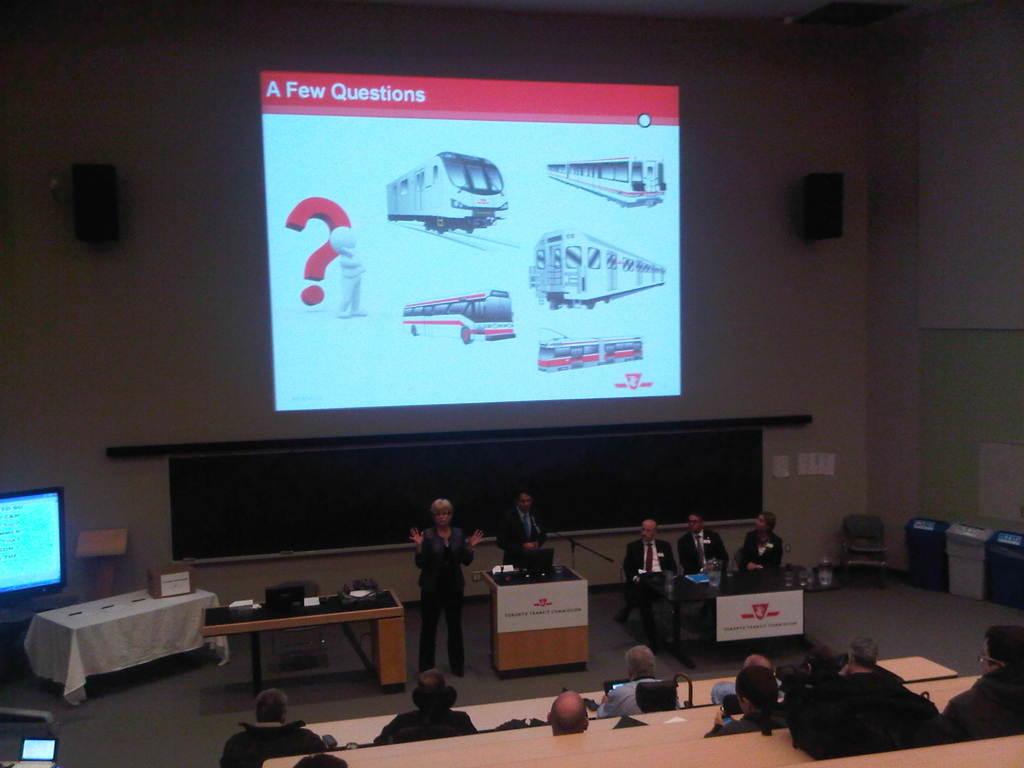What is the title of this slide?
Ensure brevity in your answer.  A few questions. 